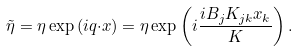Convert formula to latex. <formula><loc_0><loc_0><loc_500><loc_500>\tilde { \eta } = \eta \exp \left ( i { q } { \cdot { x } } \right ) = \eta \exp \left ( i \frac { i B _ { j } K _ { j k } x _ { k } } { K } \right ) .</formula> 